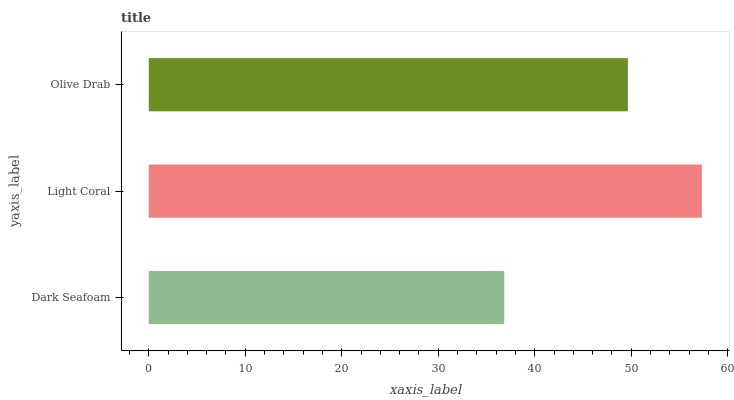Is Dark Seafoam the minimum?
Answer yes or no. Yes. Is Light Coral the maximum?
Answer yes or no. Yes. Is Olive Drab the minimum?
Answer yes or no. No. Is Olive Drab the maximum?
Answer yes or no. No. Is Light Coral greater than Olive Drab?
Answer yes or no. Yes. Is Olive Drab less than Light Coral?
Answer yes or no. Yes. Is Olive Drab greater than Light Coral?
Answer yes or no. No. Is Light Coral less than Olive Drab?
Answer yes or no. No. Is Olive Drab the high median?
Answer yes or no. Yes. Is Olive Drab the low median?
Answer yes or no. Yes. Is Light Coral the high median?
Answer yes or no. No. Is Dark Seafoam the low median?
Answer yes or no. No. 